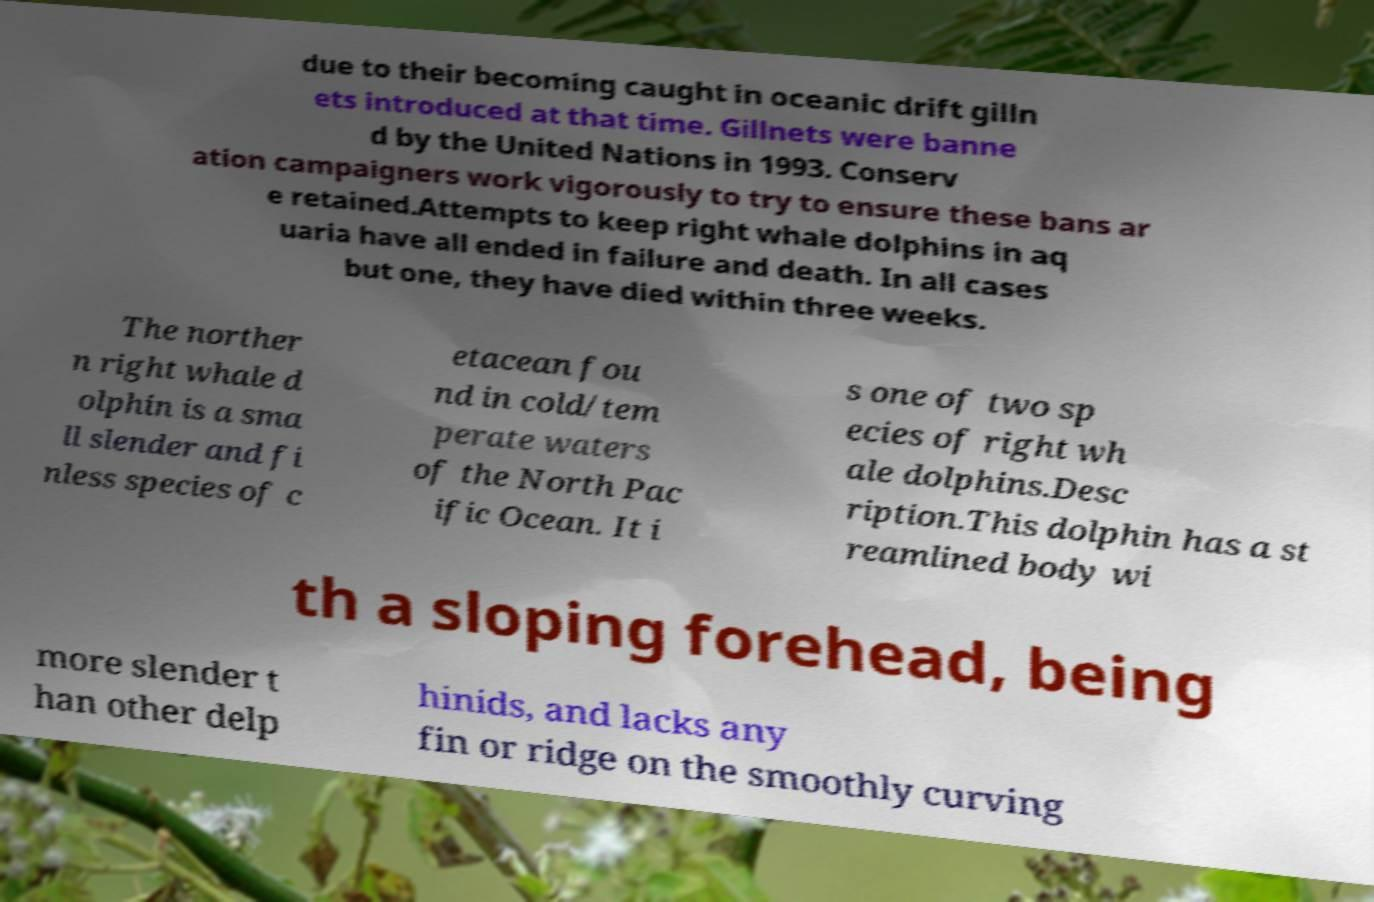Please identify and transcribe the text found in this image. due to their becoming caught in oceanic drift gilln ets introduced at that time. Gillnets were banne d by the United Nations in 1993. Conserv ation campaigners work vigorously to try to ensure these bans ar e retained.Attempts to keep right whale dolphins in aq uaria have all ended in failure and death. In all cases but one, they have died within three weeks. The norther n right whale d olphin is a sma ll slender and fi nless species of c etacean fou nd in cold/tem perate waters of the North Pac ific Ocean. It i s one of two sp ecies of right wh ale dolphins.Desc ription.This dolphin has a st reamlined body wi th a sloping forehead, being more slender t han other delp hinids, and lacks any fin or ridge on the smoothly curving 